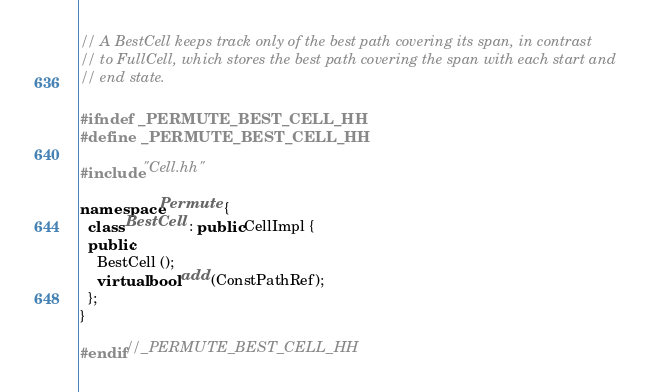<code> <loc_0><loc_0><loc_500><loc_500><_C++_>// A BestCell keeps track only of the best path covering its span, in contrast
// to FullCell, which stores the best path covering the span with each start and
// end state.

#ifndef _PERMUTE_BEST_CELL_HH
#define _PERMUTE_BEST_CELL_HH

#include "Cell.hh"

namespace Permute {
  class BestCell : public CellImpl {
  public:
    BestCell ();
    virtual bool add (ConstPathRef);
  };
}

#endif//_PERMUTE_BEST_CELL_HH
</code> 